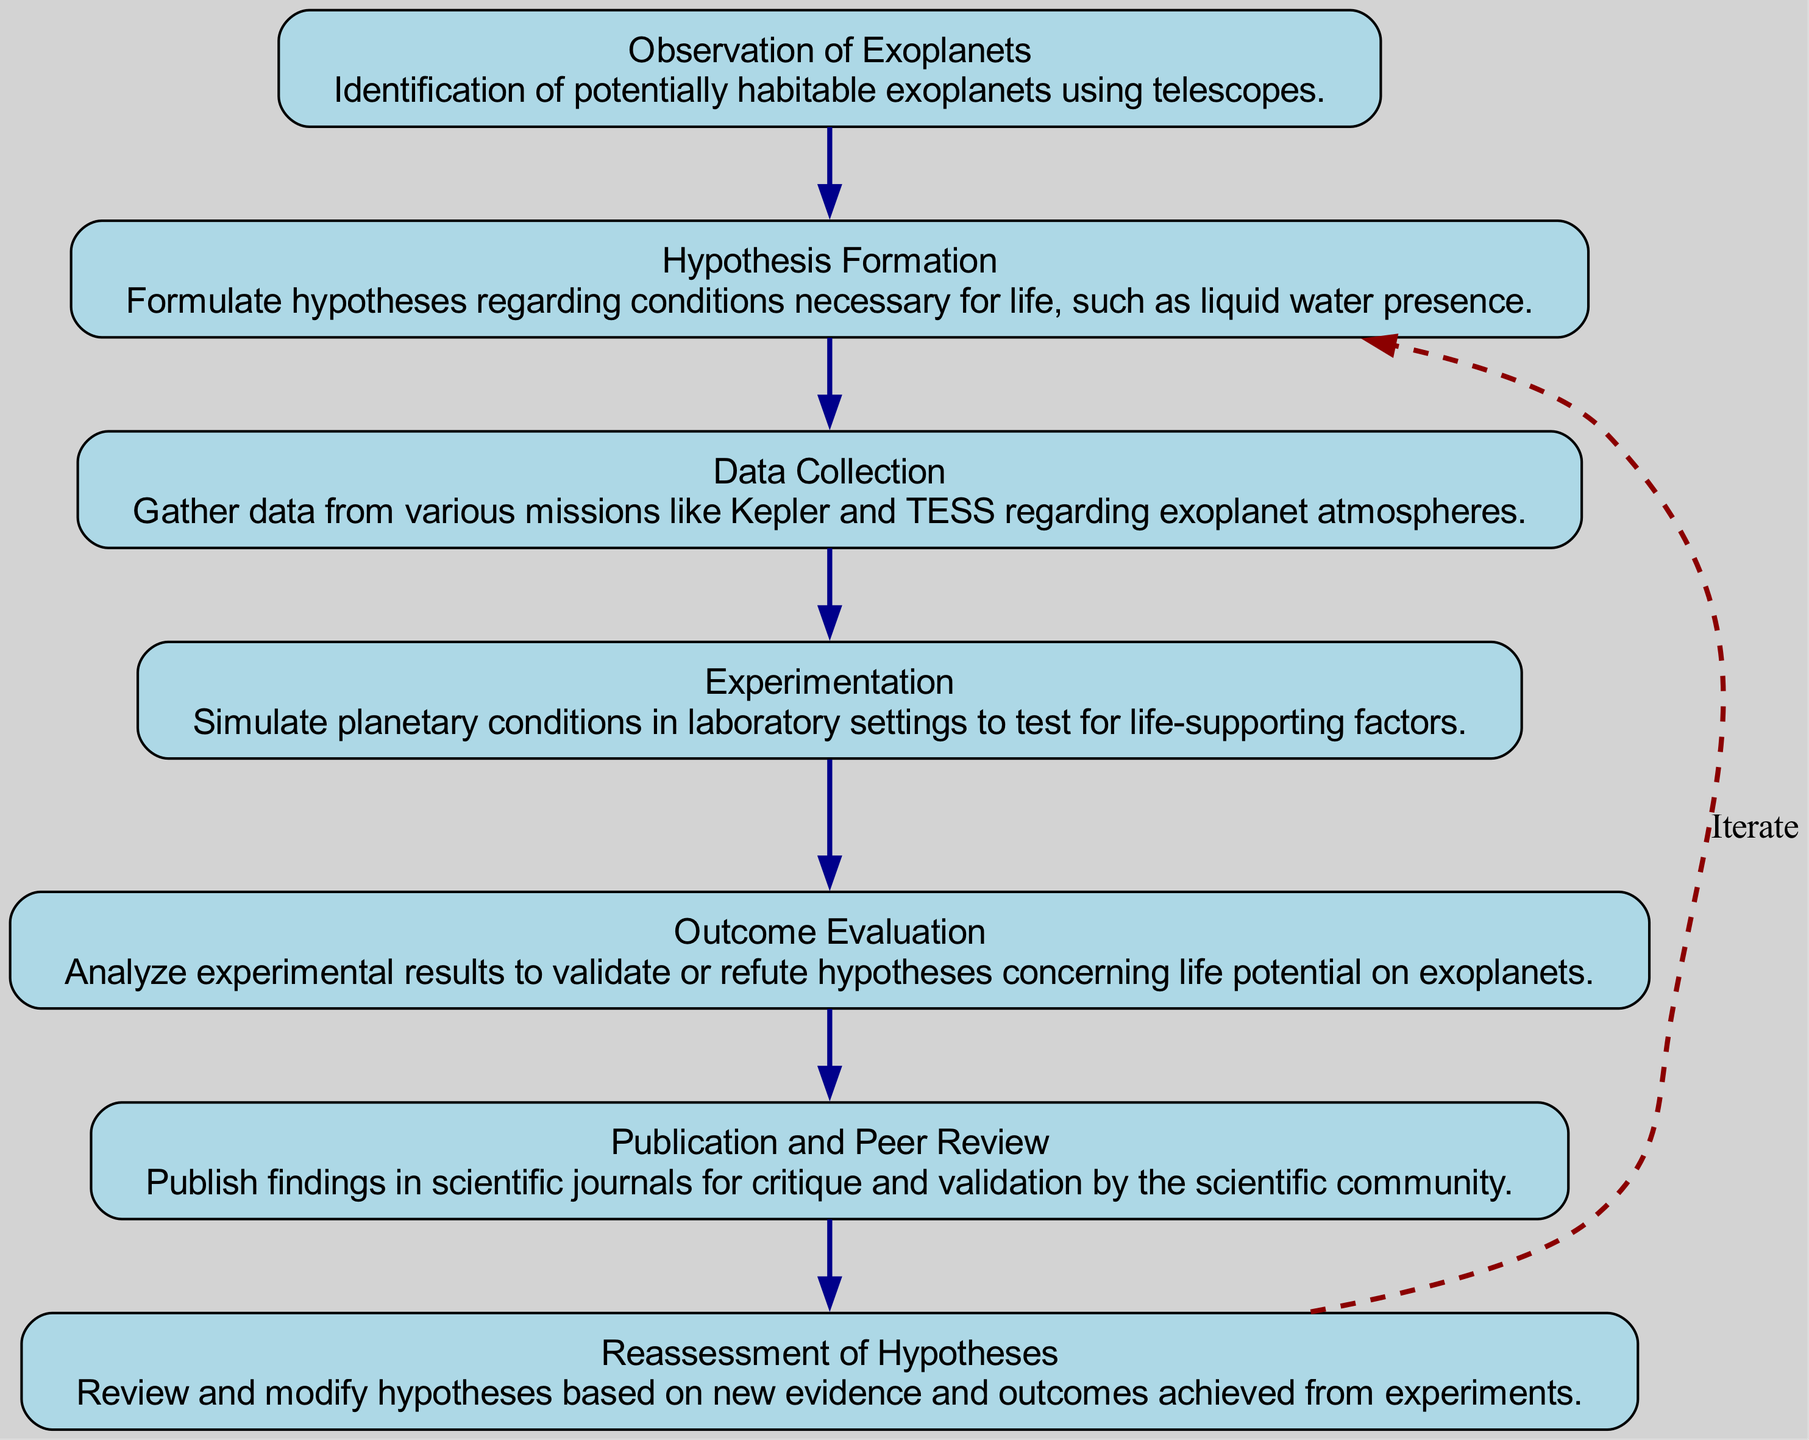What is the first step in the flow chart? The first node in the flow chart is "Observation of Exoplanets," which indicates that the initial step involves observing and identifying potentially habitable exoplanets using telescopes.
Answer: Observation of Exoplanets How many nodes are in the diagram? The diagram contains a total of seven nodes, each representing a different step in the scientific method for searching for extraterrestrial life.
Answer: seven What is the last step before publication and peer review? The last step prior to "Publication and Peer Review" is "Outcome Evaluation," which involves analyzing experimental results to validate or refute the hypotheses formed regarding life potential on exoplanets.
Answer: Outcome Evaluation Which node is related to modifying hypotheses? The node related to modifying hypotheses is "Reassessment of Hypotheses," where researchers review and adjust their hypotheses based on new evidence and experimental outcomes.
Answer: Reassessment of Hypotheses How does experimentation relate to data collection? Experimentation follows data collection in the flow, as researchers gather data from missions like Kepler and TESS and then simulate planetary conditions in laboratory settings to test for factors that support life.
Answer: Experimentation What is the relationship between outcome evaluation and reassessment of hypotheses? "Outcome Evaluation" feeds into "Reassessment of Hypotheses," suggesting that the analysis of experimental results informs the review and potential modification of the initial hypotheses.
Answer: Iteration Identify the node that first discusses the presence of liquid water. The node that first discusses the conditions necessary for life, such as liquid water presence, is "Hypothesis Formation," where hypotheses are formulated regarding these critical factors.
Answer: Hypothesis Formation How is the flow of the diagram designed? The flow of the diagram is designed to progress sequentially from "Observation of Exoplanets" to "Outcome Evaluation," and then it cycles back from "Reassessment of Hypotheses" to "Hypothesis Formation," showing an iterative process.
Answer: Sequential and Iterative 